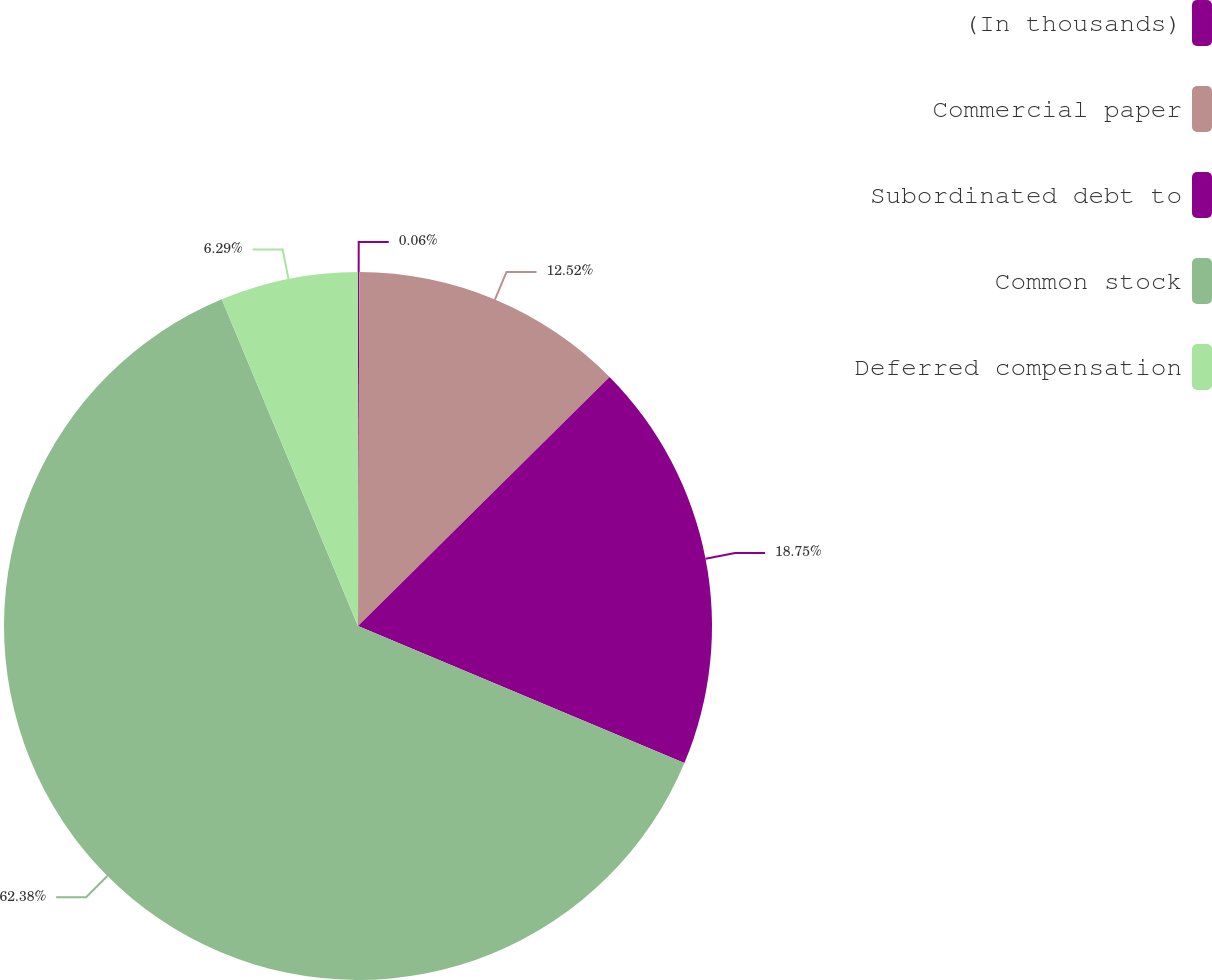Convert chart. <chart><loc_0><loc_0><loc_500><loc_500><pie_chart><fcel>(In thousands)<fcel>Commercial paper<fcel>Subordinated debt to<fcel>Common stock<fcel>Deferred compensation<nl><fcel>0.06%<fcel>12.52%<fcel>18.75%<fcel>62.38%<fcel>6.29%<nl></chart> 